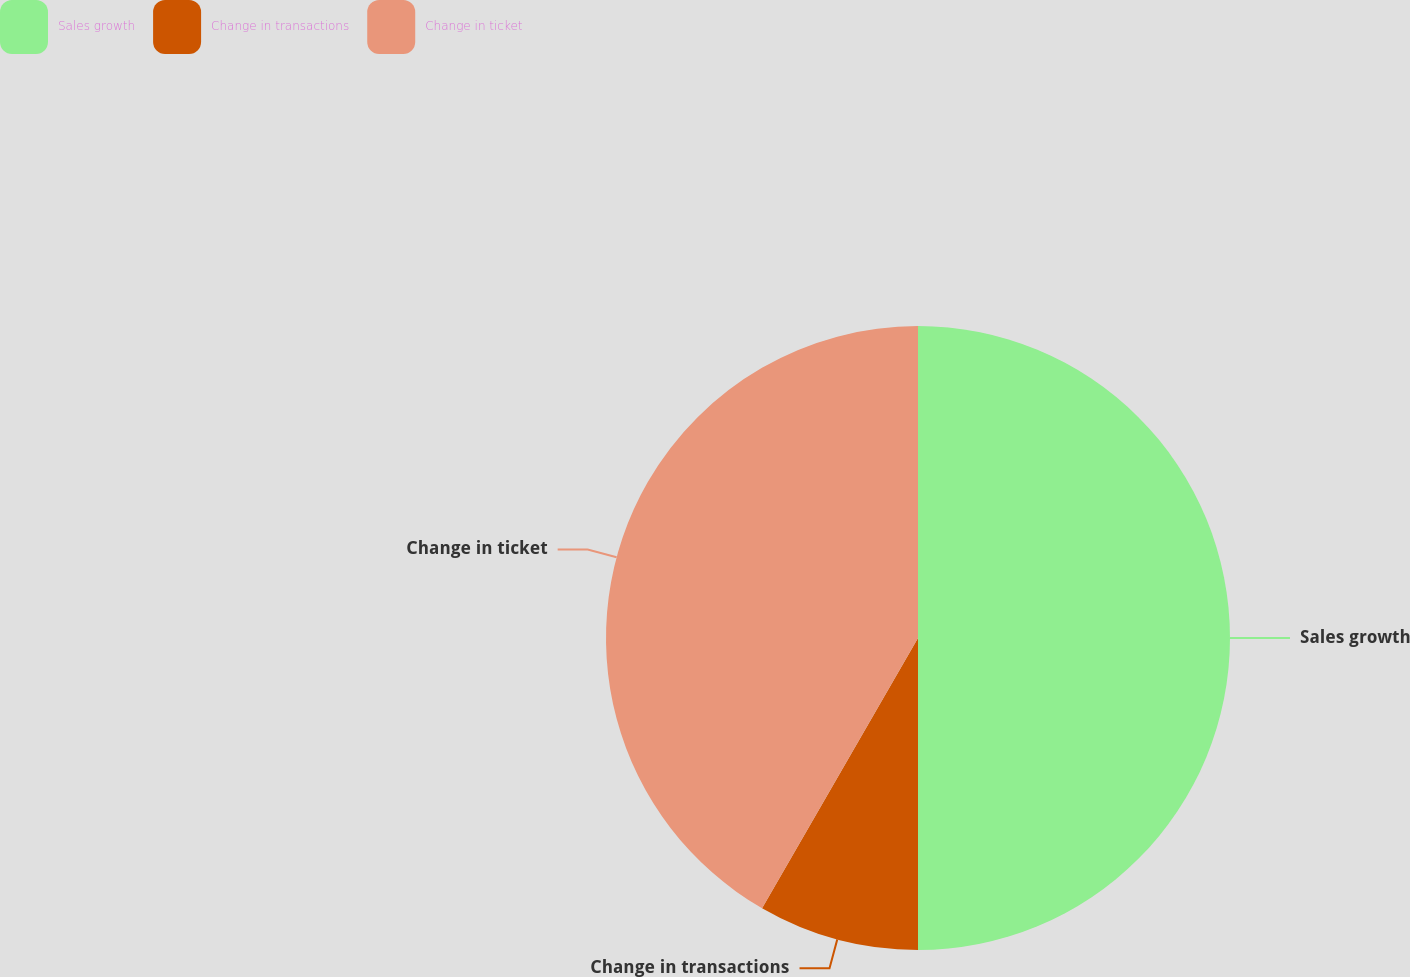<chart> <loc_0><loc_0><loc_500><loc_500><pie_chart><fcel>Sales growth<fcel>Change in transactions<fcel>Change in ticket<nl><fcel>50.0%<fcel>8.33%<fcel>41.67%<nl></chart> 